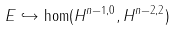<formula> <loc_0><loc_0><loc_500><loc_500>E \hookrightarrow \hom ( H ^ { n - 1 , 0 } , H ^ { n - 2 , 2 } )</formula> 